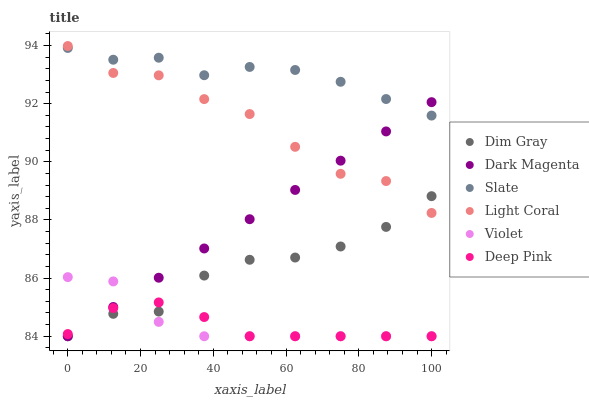Does Deep Pink have the minimum area under the curve?
Answer yes or no. Yes. Does Slate have the maximum area under the curve?
Answer yes or no. Yes. Does Dark Magenta have the minimum area under the curve?
Answer yes or no. No. Does Dark Magenta have the maximum area under the curve?
Answer yes or no. No. Is Dark Magenta the smoothest?
Answer yes or no. Yes. Is Light Coral the roughest?
Answer yes or no. Yes. Is Slate the smoothest?
Answer yes or no. No. Is Slate the roughest?
Answer yes or no. No. Does Dim Gray have the lowest value?
Answer yes or no. Yes. Does Slate have the lowest value?
Answer yes or no. No. Does Light Coral have the highest value?
Answer yes or no. Yes. Does Dark Magenta have the highest value?
Answer yes or no. No. Is Deep Pink less than Slate?
Answer yes or no. Yes. Is Light Coral greater than Deep Pink?
Answer yes or no. Yes. Does Deep Pink intersect Dim Gray?
Answer yes or no. Yes. Is Deep Pink less than Dim Gray?
Answer yes or no. No. Is Deep Pink greater than Dim Gray?
Answer yes or no. No. Does Deep Pink intersect Slate?
Answer yes or no. No. 